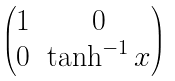<formula> <loc_0><loc_0><loc_500><loc_500>\begin{pmatrix} 1 & 0 \\ 0 & \tanh ^ { - 1 } x \end{pmatrix}</formula> 